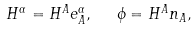<formula> <loc_0><loc_0><loc_500><loc_500>H ^ { \alpha } = H ^ { A } e _ { A } ^ { \alpha } , \text { \ } \phi = H ^ { A } n _ { A } ,</formula> 